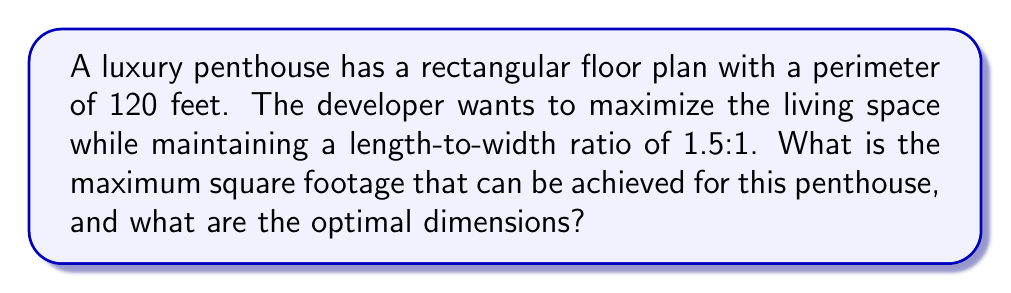Could you help me with this problem? Let's approach this step-by-step:

1) Let's define our variables:
   $w$ = width of the penthouse
   $l$ = length of the penthouse

2) Given that the length-to-width ratio is 1.5:1, we can express length in terms of width:
   $l = 1.5w$

3) We know that the perimeter is 120 feet. The formula for perimeter of a rectangle is:
   $P = 2l + 2w$
   $120 = 2(1.5w) + 2w$
   $120 = 3w + 2w$
   $120 = 5w$

4) Solve for $w$:
   $w = 120 / 5 = 24$ feet

5) Now we can calculate $l$:
   $l = 1.5w = 1.5(24) = 36$ feet

6) The area (square footage) of a rectangle is given by $A = lw$:
   $A = 36 * 24 = 864$ square feet

Therefore, the maximum square footage that can be achieved is 864 square feet, with dimensions of 36 feet by 24 feet.

This layout optimizes the use of space while maintaining the desired ratio, potentially increasing the penthouse's value and appeal to high-end buyers.
Answer: 864 sq ft; 36 ft x 24 ft 